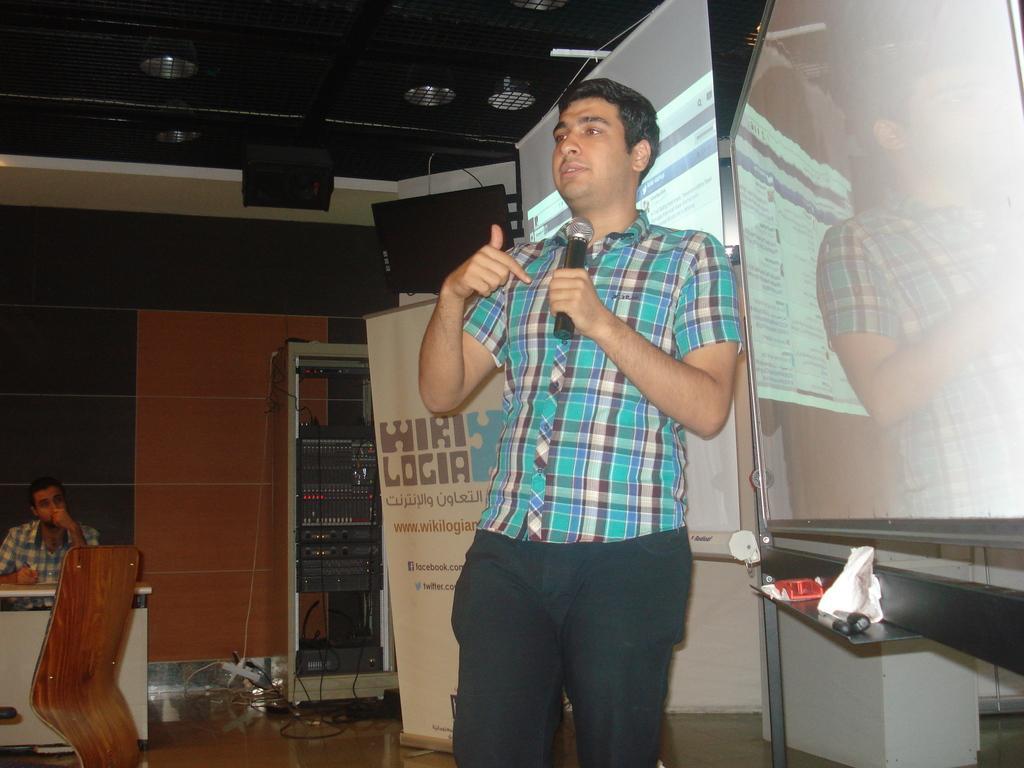Could you give a brief overview of what you see in this image? In this image there is a man holding a mike and standing on a floor, beside him there is a white board, in the background there is a screen and electrical devices and a person sitting on a chair near a table. 